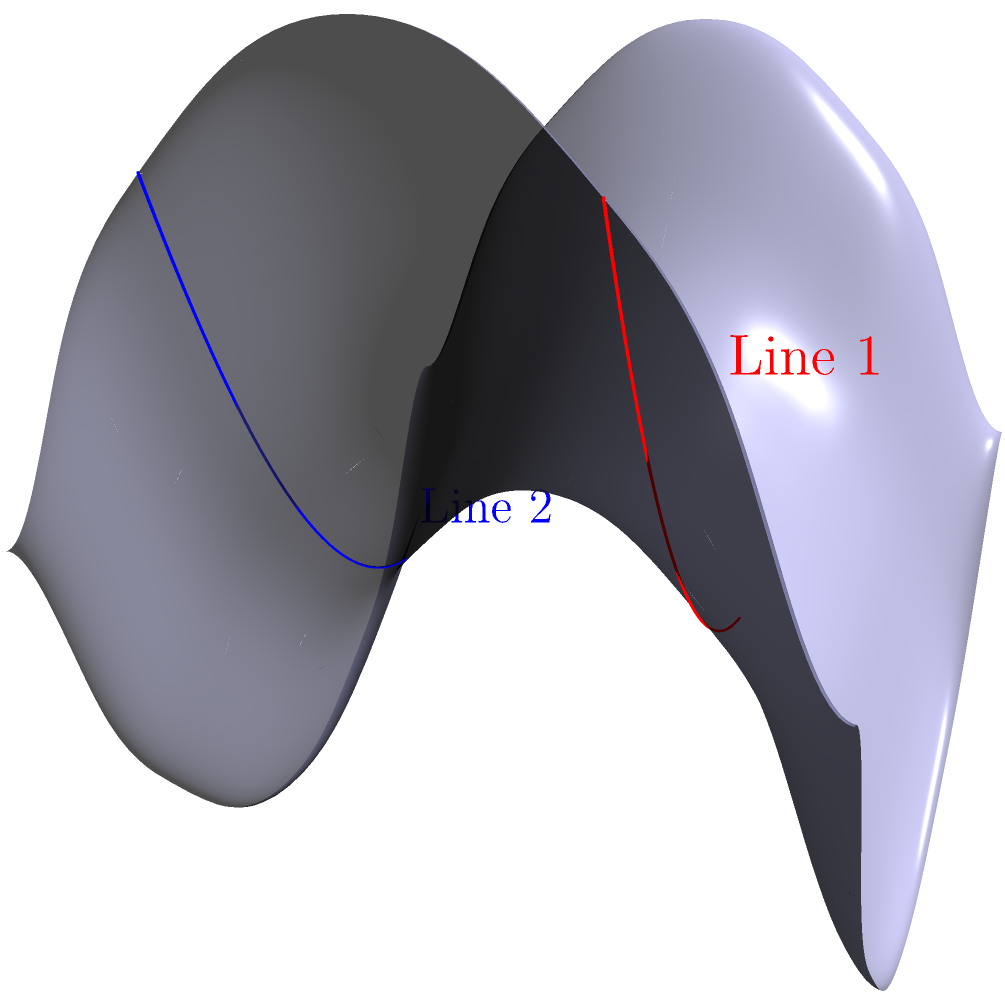In the context of disease outbreak monitoring, consider two parallel lines on a saddle-shaped surface, as shown in the diagram. If these lines represent the spread of two different strains of a virus, how would their behavior on this non-Euclidean surface differ from their behavior on a flat plane? How might this impact your interpretation of outbreak patterns? To understand the behavior of parallel lines on a saddle-shaped surface and its relevance to disease outbreak monitoring, let's follow these steps:

1. In Euclidean geometry (flat plane):
   - Parallel lines maintain a constant distance from each other.
   - They never intersect.

2. On a saddle-shaped surface (hyperbolic geometry):
   - The surface has negative curvature.
   - Parallel lines diverge from each other as they extend.

3. Behavior of the lines in the diagram:
   - Line 1 (red) and Line 2 (blue) start parallel at $x=0$.
   - As they extend along the $x$-axis, they curve away from each other.
   - This divergence is due to the negative curvature of the saddle surface.

4. Impact on disease outbreak interpretation:
   - In a flat model, parallel spread would indicate constant transmission rates.
   - On the saddle surface, diverging lines suggest:
     a) Accelerating spread in different directions.
     b) Potential for wider geographic coverage than initially expected.
     c) Increasing difficulty in containing the outbreak over time.

5. Practical implications for healthcare providers:
   - Need for dynamic resource allocation as the outbreak progresses.
   - Importance of early intervention to prevent exponential divergence.
   - Consideration of geographic and demographic factors that might contribute to non-linear spread patterns.

6. Limitations of the model:
   - Real-world disease spread is more complex than geometric models.
   - Other factors like population density, travel patterns, and interventions affect spread.

Understanding this non-Euclidean behavior can help healthcare providers anticipate and respond to unexpected patterns in disease outbreaks, potentially improving early detection and containment strategies.
Answer: Parallel lines diverge on a saddle surface, suggesting accelerating and widening disease spread patterns compared to linear models. 